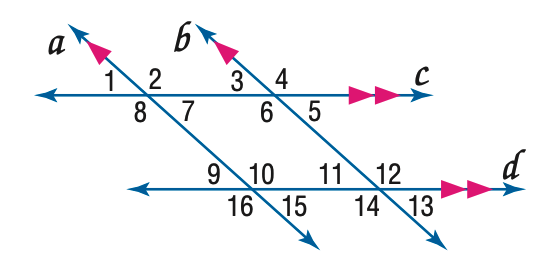Question: In the figure, m \angle 3 = 43. Find the measure of \angle 13.
Choices:
A. 33
B. 43
C. 53
D. 63
Answer with the letter. Answer: B Question: In the figure, m \angle 3 = 43. Find the measure of \angle 7.
Choices:
A. 43
B. 53
C. 127
D. 137
Answer with the letter. Answer: A Question: In the figure, m \angle 3 = 43. Find the measure of \angle 2.
Choices:
A. 43
B. 127
C. 137
D. 147
Answer with the letter. Answer: C Question: In the figure, m \angle 3 = 43. Find the measure of \angle 10.
Choices:
A. 117
B. 127
C. 137
D. 147
Answer with the letter. Answer: C Question: In the figure, m \angle 3 = 43. Find the measure of \angle 16.
Choices:
A. 117
B. 127
C. 137
D. 147
Answer with the letter. Answer: C 